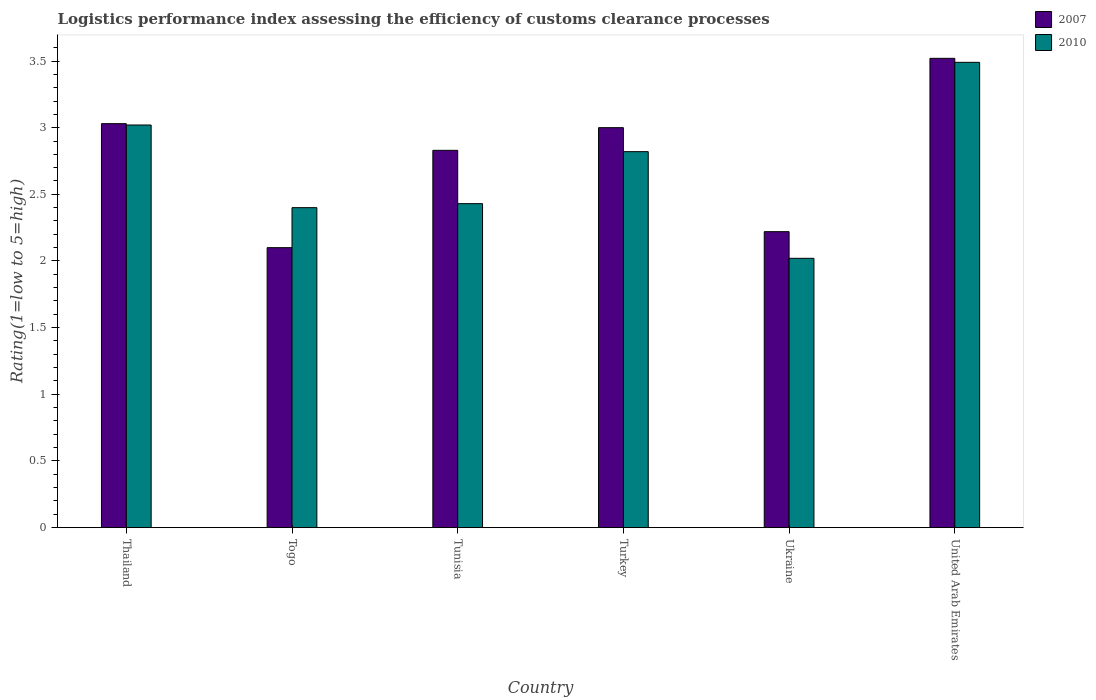How many different coloured bars are there?
Ensure brevity in your answer.  2. How many groups of bars are there?
Make the answer very short. 6. What is the label of the 6th group of bars from the left?
Offer a very short reply. United Arab Emirates. What is the Logistic performance index in 2007 in Turkey?
Your answer should be very brief. 3. Across all countries, what is the maximum Logistic performance index in 2010?
Make the answer very short. 3.49. Across all countries, what is the minimum Logistic performance index in 2007?
Ensure brevity in your answer.  2.1. In which country was the Logistic performance index in 2007 maximum?
Give a very brief answer. United Arab Emirates. In which country was the Logistic performance index in 2010 minimum?
Keep it short and to the point. Ukraine. What is the total Logistic performance index in 2010 in the graph?
Keep it short and to the point. 16.18. What is the difference between the Logistic performance index in 2007 in Thailand and that in Tunisia?
Provide a short and direct response. 0.2. What is the difference between the Logistic performance index in 2007 in Thailand and the Logistic performance index in 2010 in United Arab Emirates?
Give a very brief answer. -0.46. What is the average Logistic performance index in 2010 per country?
Keep it short and to the point. 2.7. What is the difference between the Logistic performance index of/in 2010 and Logistic performance index of/in 2007 in United Arab Emirates?
Provide a succinct answer. -0.03. In how many countries, is the Logistic performance index in 2010 greater than 2.7?
Keep it short and to the point. 3. What is the ratio of the Logistic performance index in 2010 in Thailand to that in Turkey?
Make the answer very short. 1.07. What is the difference between the highest and the second highest Logistic performance index in 2010?
Provide a succinct answer. 0.2. What is the difference between the highest and the lowest Logistic performance index in 2007?
Your answer should be very brief. 1.42. Is the sum of the Logistic performance index in 2010 in Togo and Tunisia greater than the maximum Logistic performance index in 2007 across all countries?
Offer a very short reply. Yes. What does the 2nd bar from the right in Tunisia represents?
Provide a succinct answer. 2007. What is the difference between two consecutive major ticks on the Y-axis?
Your answer should be very brief. 0.5. Does the graph contain grids?
Offer a terse response. No. How many legend labels are there?
Your response must be concise. 2. What is the title of the graph?
Your answer should be very brief. Logistics performance index assessing the efficiency of customs clearance processes. Does "1985" appear as one of the legend labels in the graph?
Offer a terse response. No. What is the label or title of the Y-axis?
Provide a short and direct response. Rating(1=low to 5=high). What is the Rating(1=low to 5=high) of 2007 in Thailand?
Ensure brevity in your answer.  3.03. What is the Rating(1=low to 5=high) of 2010 in Thailand?
Give a very brief answer. 3.02. What is the Rating(1=low to 5=high) in 2007 in Togo?
Provide a succinct answer. 2.1. What is the Rating(1=low to 5=high) of 2010 in Togo?
Ensure brevity in your answer.  2.4. What is the Rating(1=low to 5=high) of 2007 in Tunisia?
Offer a terse response. 2.83. What is the Rating(1=low to 5=high) of 2010 in Tunisia?
Provide a succinct answer. 2.43. What is the Rating(1=low to 5=high) in 2010 in Turkey?
Your answer should be compact. 2.82. What is the Rating(1=low to 5=high) of 2007 in Ukraine?
Ensure brevity in your answer.  2.22. What is the Rating(1=low to 5=high) in 2010 in Ukraine?
Make the answer very short. 2.02. What is the Rating(1=low to 5=high) of 2007 in United Arab Emirates?
Ensure brevity in your answer.  3.52. What is the Rating(1=low to 5=high) in 2010 in United Arab Emirates?
Your response must be concise. 3.49. Across all countries, what is the maximum Rating(1=low to 5=high) in 2007?
Offer a terse response. 3.52. Across all countries, what is the maximum Rating(1=low to 5=high) of 2010?
Your answer should be very brief. 3.49. Across all countries, what is the minimum Rating(1=low to 5=high) of 2010?
Provide a short and direct response. 2.02. What is the total Rating(1=low to 5=high) of 2007 in the graph?
Provide a short and direct response. 16.7. What is the total Rating(1=low to 5=high) of 2010 in the graph?
Offer a terse response. 16.18. What is the difference between the Rating(1=low to 5=high) in 2007 in Thailand and that in Togo?
Give a very brief answer. 0.93. What is the difference between the Rating(1=low to 5=high) in 2010 in Thailand and that in Togo?
Keep it short and to the point. 0.62. What is the difference between the Rating(1=low to 5=high) of 2007 in Thailand and that in Tunisia?
Your response must be concise. 0.2. What is the difference between the Rating(1=low to 5=high) of 2010 in Thailand and that in Tunisia?
Provide a succinct answer. 0.59. What is the difference between the Rating(1=low to 5=high) in 2007 in Thailand and that in Ukraine?
Your answer should be compact. 0.81. What is the difference between the Rating(1=low to 5=high) of 2010 in Thailand and that in Ukraine?
Your answer should be very brief. 1. What is the difference between the Rating(1=low to 5=high) of 2007 in Thailand and that in United Arab Emirates?
Offer a terse response. -0.49. What is the difference between the Rating(1=low to 5=high) in 2010 in Thailand and that in United Arab Emirates?
Your answer should be very brief. -0.47. What is the difference between the Rating(1=low to 5=high) in 2007 in Togo and that in Tunisia?
Provide a succinct answer. -0.73. What is the difference between the Rating(1=low to 5=high) in 2010 in Togo and that in Tunisia?
Make the answer very short. -0.03. What is the difference between the Rating(1=low to 5=high) in 2010 in Togo and that in Turkey?
Keep it short and to the point. -0.42. What is the difference between the Rating(1=low to 5=high) of 2007 in Togo and that in Ukraine?
Your answer should be compact. -0.12. What is the difference between the Rating(1=low to 5=high) of 2010 in Togo and that in Ukraine?
Offer a terse response. 0.38. What is the difference between the Rating(1=low to 5=high) of 2007 in Togo and that in United Arab Emirates?
Ensure brevity in your answer.  -1.42. What is the difference between the Rating(1=low to 5=high) in 2010 in Togo and that in United Arab Emirates?
Keep it short and to the point. -1.09. What is the difference between the Rating(1=low to 5=high) of 2007 in Tunisia and that in Turkey?
Offer a very short reply. -0.17. What is the difference between the Rating(1=low to 5=high) in 2010 in Tunisia and that in Turkey?
Your response must be concise. -0.39. What is the difference between the Rating(1=low to 5=high) in 2007 in Tunisia and that in Ukraine?
Give a very brief answer. 0.61. What is the difference between the Rating(1=low to 5=high) of 2010 in Tunisia and that in Ukraine?
Provide a succinct answer. 0.41. What is the difference between the Rating(1=low to 5=high) in 2007 in Tunisia and that in United Arab Emirates?
Provide a succinct answer. -0.69. What is the difference between the Rating(1=low to 5=high) in 2010 in Tunisia and that in United Arab Emirates?
Give a very brief answer. -1.06. What is the difference between the Rating(1=low to 5=high) of 2007 in Turkey and that in Ukraine?
Your answer should be very brief. 0.78. What is the difference between the Rating(1=low to 5=high) in 2010 in Turkey and that in Ukraine?
Ensure brevity in your answer.  0.8. What is the difference between the Rating(1=low to 5=high) in 2007 in Turkey and that in United Arab Emirates?
Make the answer very short. -0.52. What is the difference between the Rating(1=low to 5=high) of 2010 in Turkey and that in United Arab Emirates?
Offer a terse response. -0.67. What is the difference between the Rating(1=low to 5=high) in 2010 in Ukraine and that in United Arab Emirates?
Provide a short and direct response. -1.47. What is the difference between the Rating(1=low to 5=high) of 2007 in Thailand and the Rating(1=low to 5=high) of 2010 in Togo?
Give a very brief answer. 0.63. What is the difference between the Rating(1=low to 5=high) in 2007 in Thailand and the Rating(1=low to 5=high) in 2010 in Tunisia?
Your answer should be very brief. 0.6. What is the difference between the Rating(1=low to 5=high) of 2007 in Thailand and the Rating(1=low to 5=high) of 2010 in Turkey?
Provide a short and direct response. 0.21. What is the difference between the Rating(1=low to 5=high) in 2007 in Thailand and the Rating(1=low to 5=high) in 2010 in Ukraine?
Your answer should be very brief. 1.01. What is the difference between the Rating(1=low to 5=high) of 2007 in Thailand and the Rating(1=low to 5=high) of 2010 in United Arab Emirates?
Ensure brevity in your answer.  -0.46. What is the difference between the Rating(1=low to 5=high) of 2007 in Togo and the Rating(1=low to 5=high) of 2010 in Tunisia?
Offer a very short reply. -0.33. What is the difference between the Rating(1=low to 5=high) of 2007 in Togo and the Rating(1=low to 5=high) of 2010 in Turkey?
Provide a succinct answer. -0.72. What is the difference between the Rating(1=low to 5=high) of 2007 in Togo and the Rating(1=low to 5=high) of 2010 in Ukraine?
Give a very brief answer. 0.08. What is the difference between the Rating(1=low to 5=high) of 2007 in Togo and the Rating(1=low to 5=high) of 2010 in United Arab Emirates?
Ensure brevity in your answer.  -1.39. What is the difference between the Rating(1=low to 5=high) of 2007 in Tunisia and the Rating(1=low to 5=high) of 2010 in Ukraine?
Your answer should be compact. 0.81. What is the difference between the Rating(1=low to 5=high) of 2007 in Tunisia and the Rating(1=low to 5=high) of 2010 in United Arab Emirates?
Keep it short and to the point. -0.66. What is the difference between the Rating(1=low to 5=high) of 2007 in Turkey and the Rating(1=low to 5=high) of 2010 in United Arab Emirates?
Provide a short and direct response. -0.49. What is the difference between the Rating(1=low to 5=high) of 2007 in Ukraine and the Rating(1=low to 5=high) of 2010 in United Arab Emirates?
Offer a very short reply. -1.27. What is the average Rating(1=low to 5=high) of 2007 per country?
Your response must be concise. 2.78. What is the average Rating(1=low to 5=high) in 2010 per country?
Provide a succinct answer. 2.7. What is the difference between the Rating(1=low to 5=high) of 2007 and Rating(1=low to 5=high) of 2010 in Tunisia?
Your answer should be very brief. 0.4. What is the difference between the Rating(1=low to 5=high) in 2007 and Rating(1=low to 5=high) in 2010 in Turkey?
Your response must be concise. 0.18. What is the difference between the Rating(1=low to 5=high) in 2007 and Rating(1=low to 5=high) in 2010 in Ukraine?
Offer a terse response. 0.2. What is the difference between the Rating(1=low to 5=high) in 2007 and Rating(1=low to 5=high) in 2010 in United Arab Emirates?
Give a very brief answer. 0.03. What is the ratio of the Rating(1=low to 5=high) of 2007 in Thailand to that in Togo?
Your response must be concise. 1.44. What is the ratio of the Rating(1=low to 5=high) in 2010 in Thailand to that in Togo?
Provide a short and direct response. 1.26. What is the ratio of the Rating(1=low to 5=high) of 2007 in Thailand to that in Tunisia?
Provide a succinct answer. 1.07. What is the ratio of the Rating(1=low to 5=high) in 2010 in Thailand to that in Tunisia?
Provide a short and direct response. 1.24. What is the ratio of the Rating(1=low to 5=high) in 2010 in Thailand to that in Turkey?
Provide a succinct answer. 1.07. What is the ratio of the Rating(1=low to 5=high) in 2007 in Thailand to that in Ukraine?
Provide a short and direct response. 1.36. What is the ratio of the Rating(1=low to 5=high) in 2010 in Thailand to that in Ukraine?
Ensure brevity in your answer.  1.5. What is the ratio of the Rating(1=low to 5=high) in 2007 in Thailand to that in United Arab Emirates?
Keep it short and to the point. 0.86. What is the ratio of the Rating(1=low to 5=high) of 2010 in Thailand to that in United Arab Emirates?
Your answer should be very brief. 0.87. What is the ratio of the Rating(1=low to 5=high) in 2007 in Togo to that in Tunisia?
Keep it short and to the point. 0.74. What is the ratio of the Rating(1=low to 5=high) of 2010 in Togo to that in Tunisia?
Offer a very short reply. 0.99. What is the ratio of the Rating(1=low to 5=high) of 2007 in Togo to that in Turkey?
Your response must be concise. 0.7. What is the ratio of the Rating(1=low to 5=high) of 2010 in Togo to that in Turkey?
Keep it short and to the point. 0.85. What is the ratio of the Rating(1=low to 5=high) in 2007 in Togo to that in Ukraine?
Ensure brevity in your answer.  0.95. What is the ratio of the Rating(1=low to 5=high) of 2010 in Togo to that in Ukraine?
Provide a succinct answer. 1.19. What is the ratio of the Rating(1=low to 5=high) of 2007 in Togo to that in United Arab Emirates?
Keep it short and to the point. 0.6. What is the ratio of the Rating(1=low to 5=high) in 2010 in Togo to that in United Arab Emirates?
Keep it short and to the point. 0.69. What is the ratio of the Rating(1=low to 5=high) in 2007 in Tunisia to that in Turkey?
Offer a terse response. 0.94. What is the ratio of the Rating(1=low to 5=high) in 2010 in Tunisia to that in Turkey?
Your response must be concise. 0.86. What is the ratio of the Rating(1=low to 5=high) in 2007 in Tunisia to that in Ukraine?
Offer a terse response. 1.27. What is the ratio of the Rating(1=low to 5=high) in 2010 in Tunisia to that in Ukraine?
Your answer should be very brief. 1.2. What is the ratio of the Rating(1=low to 5=high) in 2007 in Tunisia to that in United Arab Emirates?
Your answer should be compact. 0.8. What is the ratio of the Rating(1=low to 5=high) of 2010 in Tunisia to that in United Arab Emirates?
Give a very brief answer. 0.7. What is the ratio of the Rating(1=low to 5=high) of 2007 in Turkey to that in Ukraine?
Your answer should be compact. 1.35. What is the ratio of the Rating(1=low to 5=high) in 2010 in Turkey to that in Ukraine?
Your response must be concise. 1.4. What is the ratio of the Rating(1=low to 5=high) of 2007 in Turkey to that in United Arab Emirates?
Keep it short and to the point. 0.85. What is the ratio of the Rating(1=low to 5=high) of 2010 in Turkey to that in United Arab Emirates?
Provide a succinct answer. 0.81. What is the ratio of the Rating(1=low to 5=high) in 2007 in Ukraine to that in United Arab Emirates?
Provide a succinct answer. 0.63. What is the ratio of the Rating(1=low to 5=high) in 2010 in Ukraine to that in United Arab Emirates?
Ensure brevity in your answer.  0.58. What is the difference between the highest and the second highest Rating(1=low to 5=high) of 2007?
Keep it short and to the point. 0.49. What is the difference between the highest and the second highest Rating(1=low to 5=high) in 2010?
Your answer should be compact. 0.47. What is the difference between the highest and the lowest Rating(1=low to 5=high) in 2007?
Ensure brevity in your answer.  1.42. What is the difference between the highest and the lowest Rating(1=low to 5=high) in 2010?
Your answer should be very brief. 1.47. 